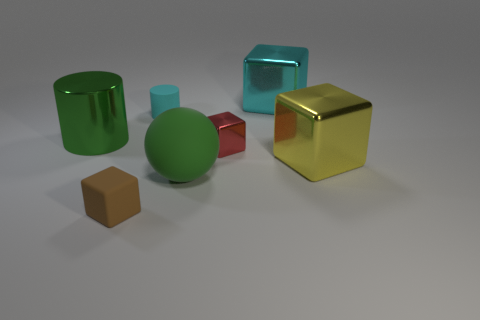Add 1 cyan matte things. How many objects exist? 8 Subtract all cubes. How many objects are left? 3 Subtract 0 gray cylinders. How many objects are left? 7 Subtract all big objects. Subtract all matte objects. How many objects are left? 0 Add 5 red objects. How many red objects are left? 6 Add 7 red rubber cylinders. How many red rubber cylinders exist? 7 